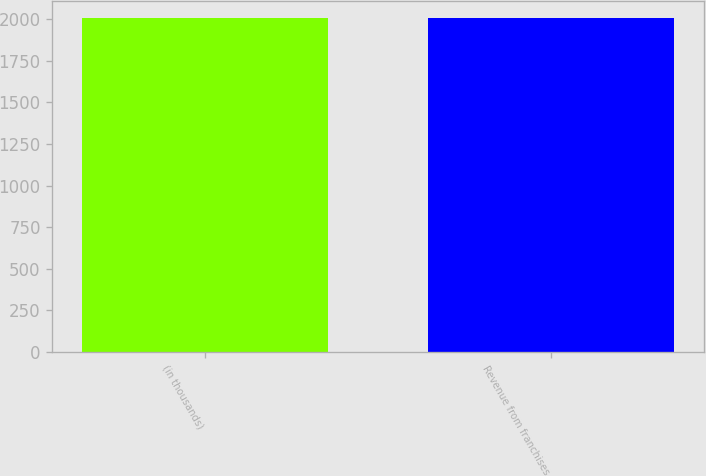<chart> <loc_0><loc_0><loc_500><loc_500><bar_chart><fcel>(in thousands)<fcel>Revenue from franchises<nl><fcel>2005<fcel>2006<nl></chart> 